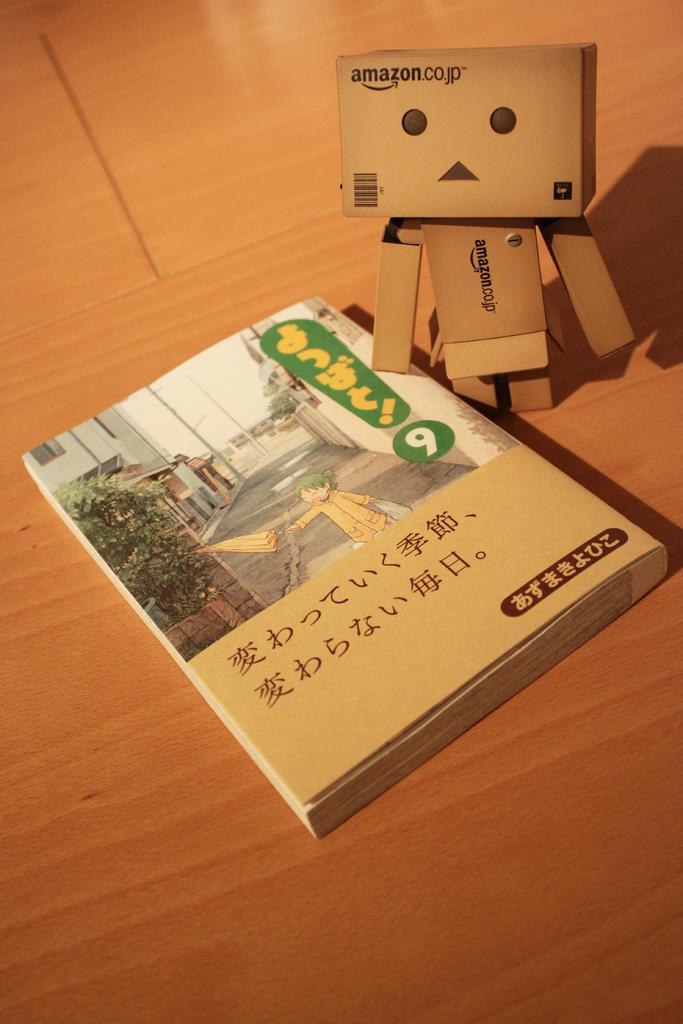Provide a one-sentence caption for the provided image. a book in Japanese next to a box person with words Amazon.co.jp. 